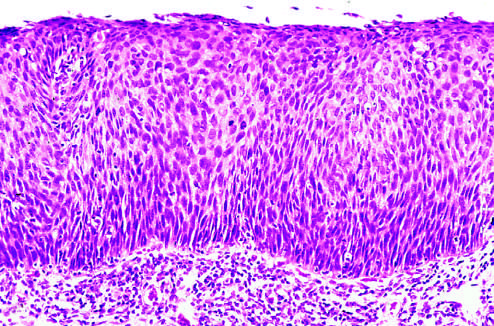s margin p orderly differentiation of squamous cells?
Answer the question using a single word or phrase. No 